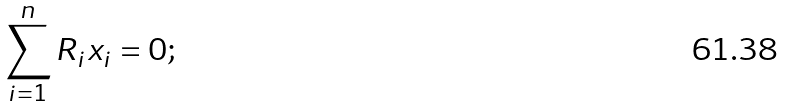Convert formula to latex. <formula><loc_0><loc_0><loc_500><loc_500>\sum _ { i = 1 } ^ { n } R _ { i } x _ { i } = 0 ;</formula> 